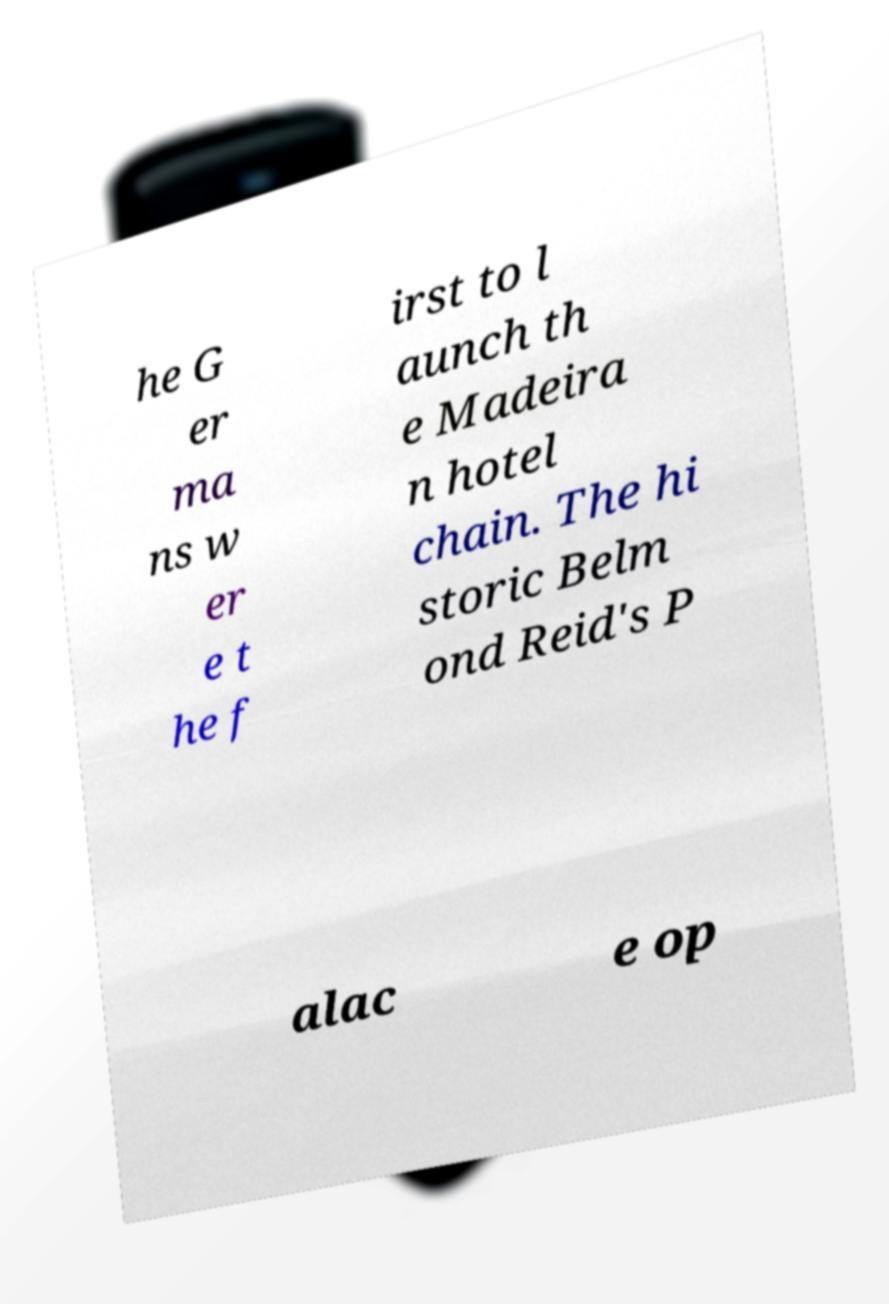Please read and relay the text visible in this image. What does it say? he G er ma ns w er e t he f irst to l aunch th e Madeira n hotel chain. The hi storic Belm ond Reid's P alac e op 